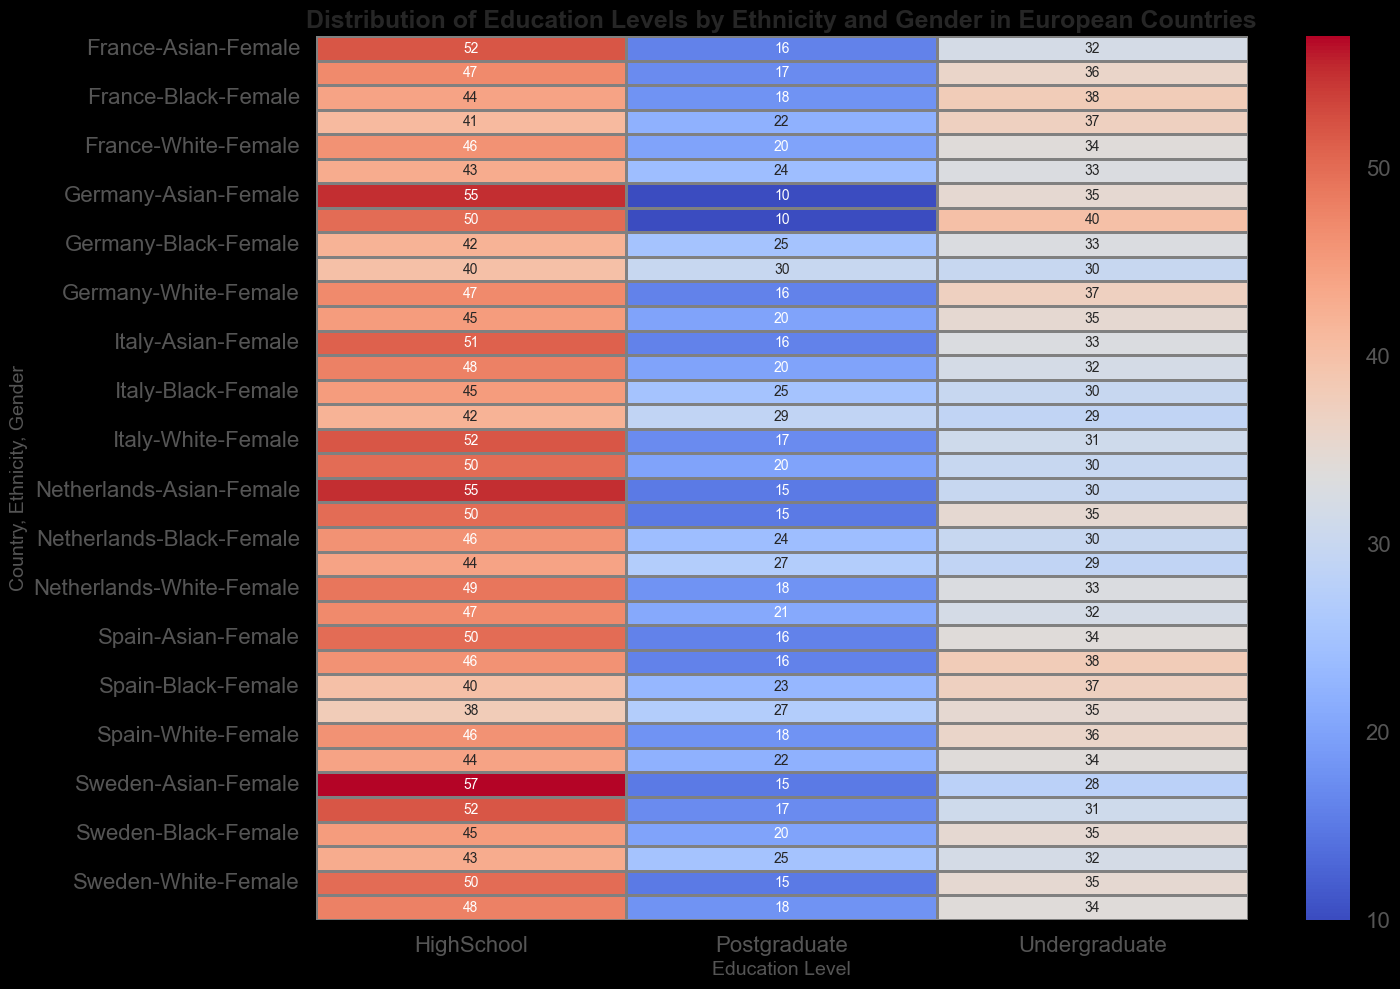Which gender has the highest percentage of Postgraduates in Germany among all ethnicities? To find the answer, we look at Postgraduate percentages for each ethnicity and gender in Germany. For Whites, Males have 20% and Females have 16%. For Blacks, Males have 30% and Females have 25%. For Asians, Males have 10% and Females have 10%. Therefore, among all ethnicities, Black Males have the highest percentage of Postgraduates at 30%.
Answer: Black Males What is the difference in HighSchool education levels between White and Black males in Spain? We need to find the HighSchool percentages for White and Black males in Spain. White Males have 44% and Black Males have 38%. The difference is 44% - 38% = 6%.
Answer: 6% Which country has the highest percentage of HighSchool education level among Asian Females? By examining the values for Asian Females across countries, we see Germany has 55%, France 52%, Italy 51%, Spain 50%, Netherlands 55%, and Sweden 57%. Therefore, Sweden has the highest percentage at 57%.
Answer: Sweden Compare the Undergraduate education level between White Females in France and Italy. Which is higher? We need to compare the Undergraduate percentages for White Females in France and Italy. White Females in France have 34% while in Italy they have 31%. Therefore, France is higher.
Answer: France What is the total percentage of Postgraduates for all ethnicities in the Netherlands? Summing up the Postgraduate percentages for all ethnicities in the Netherlands: White Males 21%, White Females 18%, Black Males 27%, Black Females 24%, Asian Males 15%, and Asian Females 15%. Total = 21 + 18 + 27 + 24 + 15 + 15 = 120%.
Answer: 120% Which gender generally has higher percentages of undergraduate education levels in Germany, Male or Female? We look at the Undergraduate percentages for both genders in Germany across all ethnicities. For Whites, Males have 35% and Females have 37%. For Blacks, Males have 30% and Females have 33%. For Asians, Males have 40% and Females have 35%. Since 37% > 35%, 33% > 30%, but 40% > 35%, it is mixed. However, averaging them (Weighted averages): Males 35%, Females 35% produces no clear winner.
Answer: Mixed What is the percentage difference in Postgraduates between White Males and Black Females in France? Postgraduate percentages in France for White Males are 24% and for Black Females are 18%. Difference is 24% - 18% = 6%.
Answer: 6% In Italy, which ethnicity has the lowest percentage of HighSchool education for females? Examining the HighSchool percentages for females in Italy: White Females 52%, Black Females 45%, and Asian Females 51%. Black Females have the lowest percentage at 45%.
Answer: Black Between Spain and Germany, which country has a higher Undergraduate percentage for Asian males? Comparing Undergraduate percentages for Asian males: Spain has 38% while Germany has 40%. Therefore, Germany is higher.
Answer: Germany 